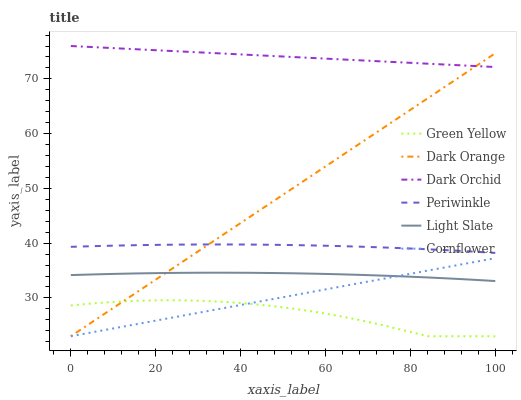Does Green Yellow have the minimum area under the curve?
Answer yes or no. Yes. Does Dark Orchid have the maximum area under the curve?
Answer yes or no. Yes. Does Cornflower have the minimum area under the curve?
Answer yes or no. No. Does Cornflower have the maximum area under the curve?
Answer yes or no. No. Is Cornflower the smoothest?
Answer yes or no. Yes. Is Green Yellow the roughest?
Answer yes or no. Yes. Is Light Slate the smoothest?
Answer yes or no. No. Is Light Slate the roughest?
Answer yes or no. No. Does Dark Orange have the lowest value?
Answer yes or no. Yes. Does Light Slate have the lowest value?
Answer yes or no. No. Does Dark Orchid have the highest value?
Answer yes or no. Yes. Does Cornflower have the highest value?
Answer yes or no. No. Is Cornflower less than Periwinkle?
Answer yes or no. Yes. Is Dark Orchid greater than Cornflower?
Answer yes or no. Yes. Does Dark Orange intersect Cornflower?
Answer yes or no. Yes. Is Dark Orange less than Cornflower?
Answer yes or no. No. Is Dark Orange greater than Cornflower?
Answer yes or no. No. Does Cornflower intersect Periwinkle?
Answer yes or no. No. 